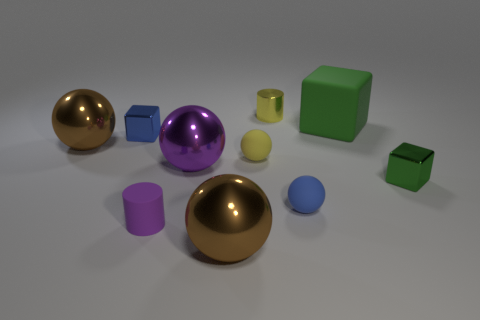Subtract all yellow balls. How many balls are left? 4 Subtract all brown cylinders. How many green blocks are left? 2 Subtract 3 spheres. How many spheres are left? 2 Subtract all yellow balls. How many balls are left? 4 Subtract all blocks. How many objects are left? 7 Subtract all big green cylinders. Subtract all big rubber objects. How many objects are left? 9 Add 2 matte cylinders. How many matte cylinders are left? 3 Add 6 small yellow matte objects. How many small yellow matte objects exist? 7 Subtract 1 purple spheres. How many objects are left? 9 Subtract all purple cylinders. Subtract all green balls. How many cylinders are left? 1 